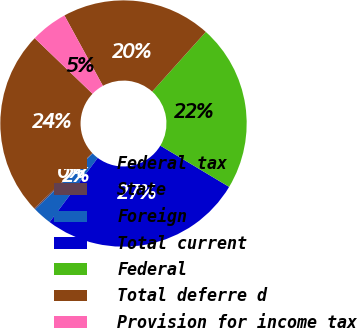Convert chart. <chart><loc_0><loc_0><loc_500><loc_500><pie_chart><fcel>Federal tax<fcel>State<fcel>Foreign<fcel>Total current<fcel>Federal<fcel>Total deferre d<fcel>Provision for income tax<nl><fcel>24.29%<fcel>0.16%<fcel>2.5%<fcel>26.64%<fcel>21.95%<fcel>19.61%<fcel>4.85%<nl></chart> 